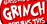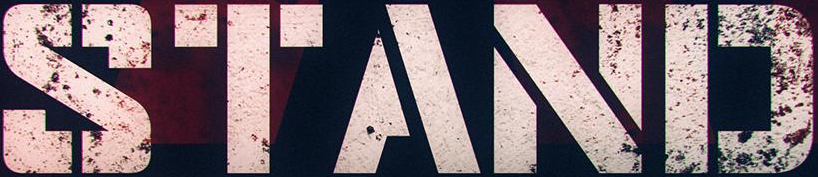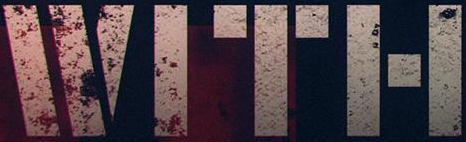What words can you see in these images in sequence, separated by a semicolon? GRINGH; STAND; WITH 